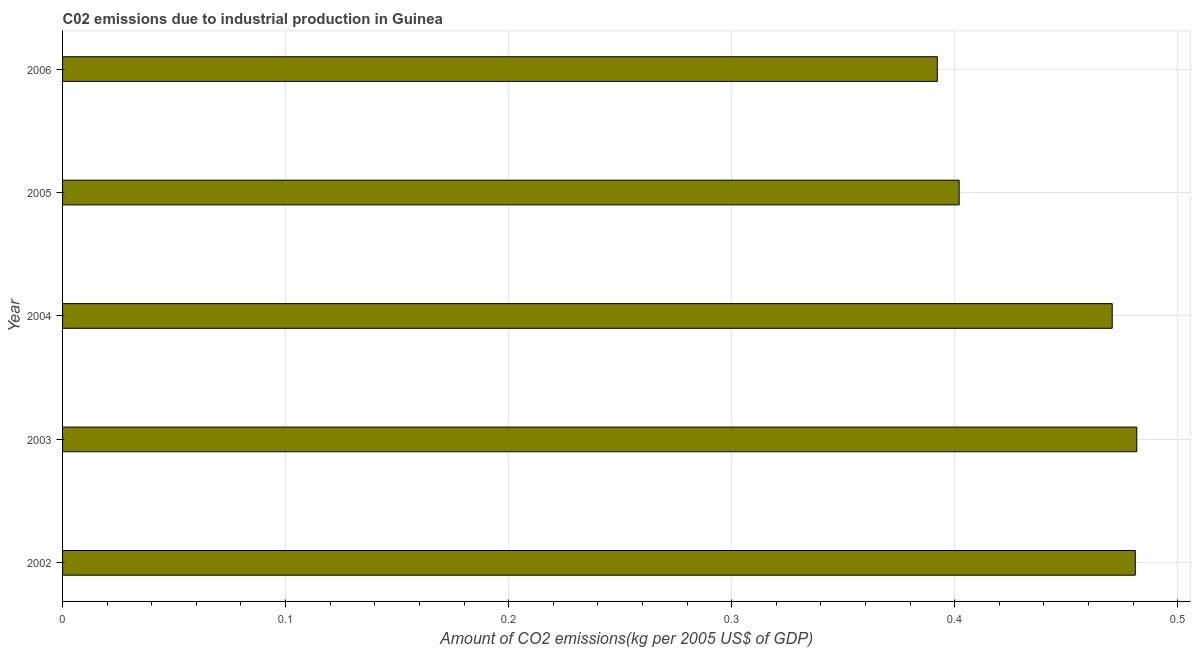Does the graph contain grids?
Your response must be concise. Yes. What is the title of the graph?
Provide a succinct answer. C02 emissions due to industrial production in Guinea. What is the label or title of the X-axis?
Your answer should be very brief. Amount of CO2 emissions(kg per 2005 US$ of GDP). What is the label or title of the Y-axis?
Keep it short and to the point. Year. What is the amount of co2 emissions in 2005?
Your answer should be compact. 0.4. Across all years, what is the maximum amount of co2 emissions?
Your answer should be very brief. 0.48. Across all years, what is the minimum amount of co2 emissions?
Give a very brief answer. 0.39. In which year was the amount of co2 emissions maximum?
Your answer should be very brief. 2003. What is the sum of the amount of co2 emissions?
Make the answer very short. 2.23. What is the difference between the amount of co2 emissions in 2003 and 2004?
Offer a terse response. 0.01. What is the average amount of co2 emissions per year?
Offer a terse response. 0.45. What is the median amount of co2 emissions?
Give a very brief answer. 0.47. Do a majority of the years between 2002 and 2003 (inclusive) have amount of co2 emissions greater than 0.02 kg per 2005 US$ of GDP?
Provide a succinct answer. Yes. What is the difference between the highest and the second highest amount of co2 emissions?
Provide a short and direct response. 0. Is the sum of the amount of co2 emissions in 2004 and 2005 greater than the maximum amount of co2 emissions across all years?
Offer a very short reply. Yes. What is the difference between the highest and the lowest amount of co2 emissions?
Keep it short and to the point. 0.09. How many bars are there?
Your response must be concise. 5. Are all the bars in the graph horizontal?
Ensure brevity in your answer.  Yes. What is the difference between two consecutive major ticks on the X-axis?
Make the answer very short. 0.1. Are the values on the major ticks of X-axis written in scientific E-notation?
Keep it short and to the point. No. What is the Amount of CO2 emissions(kg per 2005 US$ of GDP) in 2002?
Offer a terse response. 0.48. What is the Amount of CO2 emissions(kg per 2005 US$ of GDP) of 2003?
Give a very brief answer. 0.48. What is the Amount of CO2 emissions(kg per 2005 US$ of GDP) of 2004?
Give a very brief answer. 0.47. What is the Amount of CO2 emissions(kg per 2005 US$ of GDP) of 2005?
Provide a short and direct response. 0.4. What is the Amount of CO2 emissions(kg per 2005 US$ of GDP) of 2006?
Offer a terse response. 0.39. What is the difference between the Amount of CO2 emissions(kg per 2005 US$ of GDP) in 2002 and 2003?
Offer a terse response. -0. What is the difference between the Amount of CO2 emissions(kg per 2005 US$ of GDP) in 2002 and 2004?
Offer a terse response. 0.01. What is the difference between the Amount of CO2 emissions(kg per 2005 US$ of GDP) in 2002 and 2005?
Keep it short and to the point. 0.08. What is the difference between the Amount of CO2 emissions(kg per 2005 US$ of GDP) in 2002 and 2006?
Your answer should be very brief. 0.09. What is the difference between the Amount of CO2 emissions(kg per 2005 US$ of GDP) in 2003 and 2004?
Provide a succinct answer. 0.01. What is the difference between the Amount of CO2 emissions(kg per 2005 US$ of GDP) in 2003 and 2005?
Ensure brevity in your answer.  0.08. What is the difference between the Amount of CO2 emissions(kg per 2005 US$ of GDP) in 2003 and 2006?
Ensure brevity in your answer.  0.09. What is the difference between the Amount of CO2 emissions(kg per 2005 US$ of GDP) in 2004 and 2005?
Offer a terse response. 0.07. What is the difference between the Amount of CO2 emissions(kg per 2005 US$ of GDP) in 2004 and 2006?
Your answer should be compact. 0.08. What is the difference between the Amount of CO2 emissions(kg per 2005 US$ of GDP) in 2005 and 2006?
Make the answer very short. 0.01. What is the ratio of the Amount of CO2 emissions(kg per 2005 US$ of GDP) in 2002 to that in 2003?
Make the answer very short. 1. What is the ratio of the Amount of CO2 emissions(kg per 2005 US$ of GDP) in 2002 to that in 2005?
Your response must be concise. 1.2. What is the ratio of the Amount of CO2 emissions(kg per 2005 US$ of GDP) in 2002 to that in 2006?
Your answer should be compact. 1.23. What is the ratio of the Amount of CO2 emissions(kg per 2005 US$ of GDP) in 2003 to that in 2004?
Offer a terse response. 1.02. What is the ratio of the Amount of CO2 emissions(kg per 2005 US$ of GDP) in 2003 to that in 2005?
Provide a short and direct response. 1.2. What is the ratio of the Amount of CO2 emissions(kg per 2005 US$ of GDP) in 2003 to that in 2006?
Your answer should be compact. 1.23. What is the ratio of the Amount of CO2 emissions(kg per 2005 US$ of GDP) in 2004 to that in 2005?
Offer a terse response. 1.17. What is the ratio of the Amount of CO2 emissions(kg per 2005 US$ of GDP) in 2004 to that in 2006?
Provide a succinct answer. 1.2. 